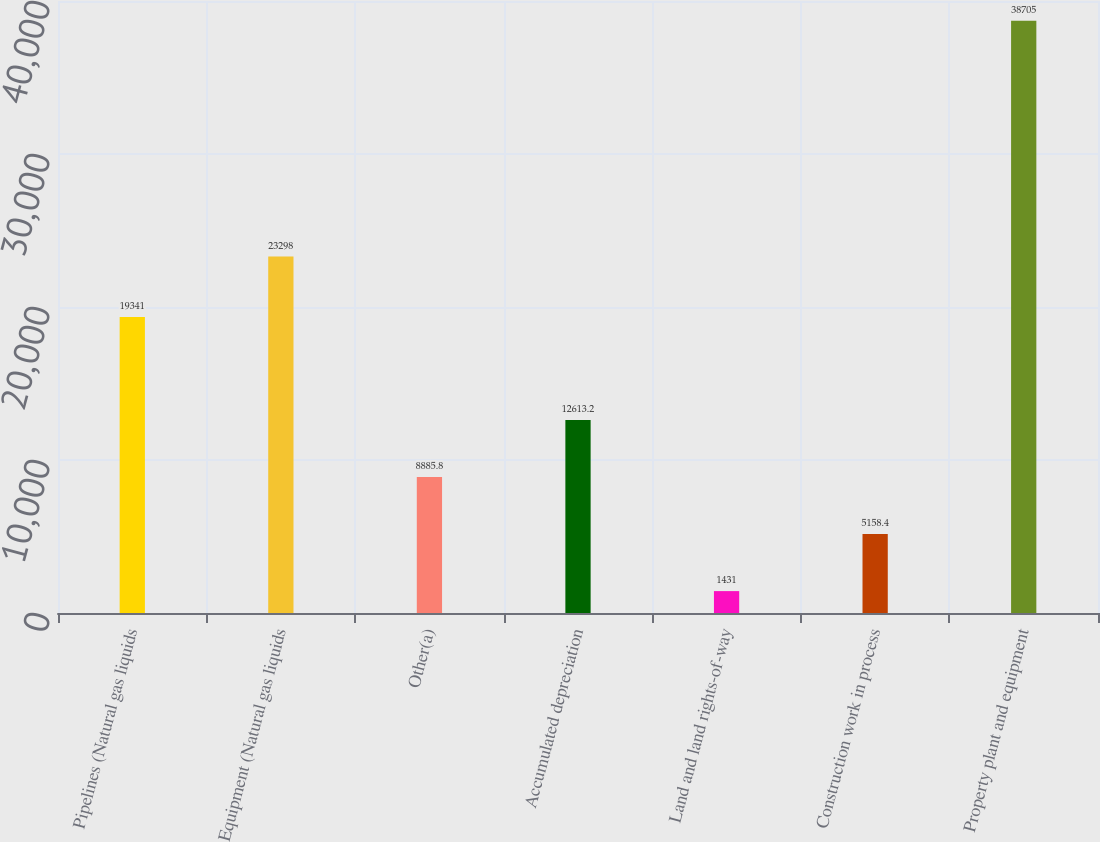<chart> <loc_0><loc_0><loc_500><loc_500><bar_chart><fcel>Pipelines (Natural gas liquids<fcel>Equipment (Natural gas liquids<fcel>Other(a)<fcel>Accumulated depreciation<fcel>Land and land rights-of-way<fcel>Construction work in process<fcel>Property plant and equipment<nl><fcel>19341<fcel>23298<fcel>8885.8<fcel>12613.2<fcel>1431<fcel>5158.4<fcel>38705<nl></chart> 